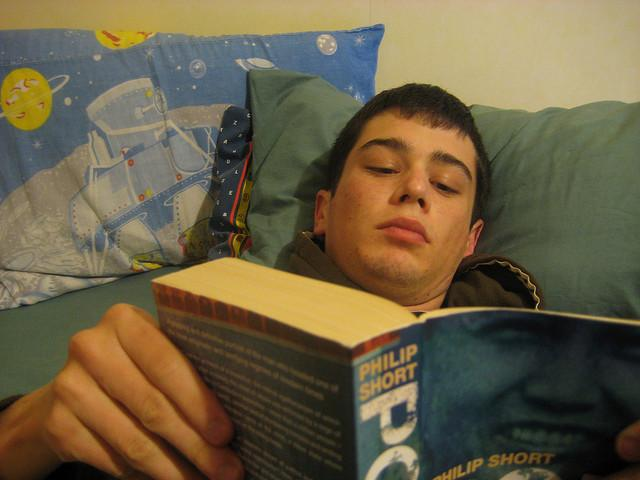What is the boy doing with the book?

Choices:
A) highlighting it
B) tearing it
C) burning it
D) reading it reading it 